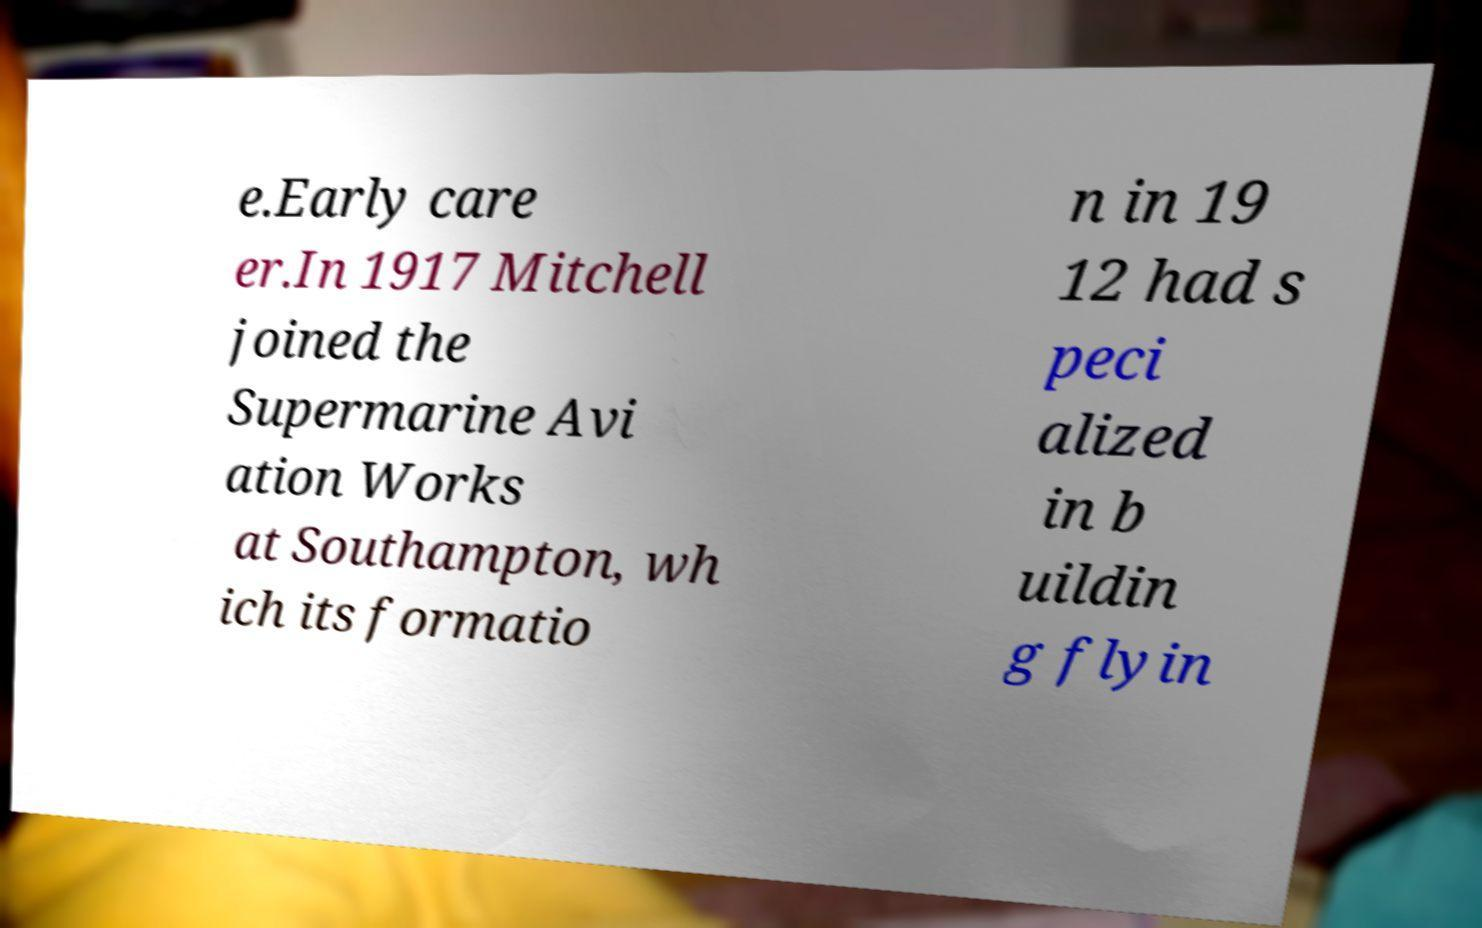Could you assist in decoding the text presented in this image and type it out clearly? e.Early care er.In 1917 Mitchell joined the Supermarine Avi ation Works at Southampton, wh ich its formatio n in 19 12 had s peci alized in b uildin g flyin 